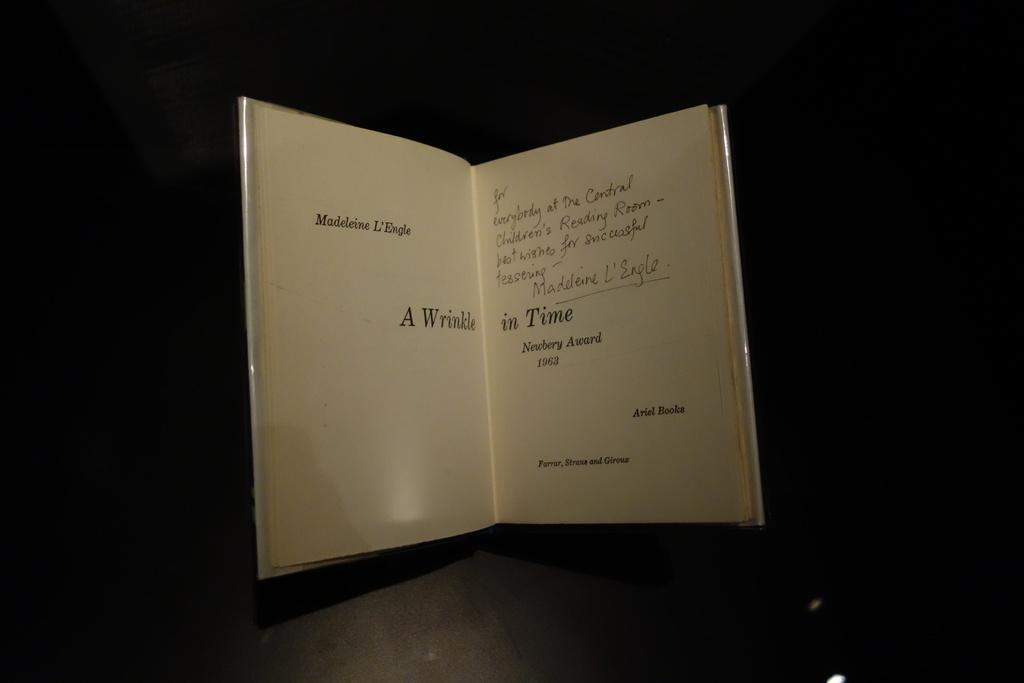What is the main object in the image? There is an open book in the image. What can be seen inside the book? There is text visible in the book. How would you describe the overall appearance of the image? The background of the image is dark. Can you tell me what type of request the toad is making in the image? There is no toad present in the image, so it is not possible to determine what type of request it might be making. 